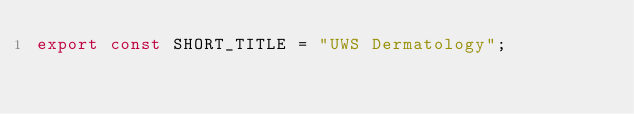<code> <loc_0><loc_0><loc_500><loc_500><_JavaScript_>export const SHORT_TITLE = "UWS Dermatology";</code> 